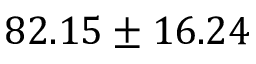Convert formula to latex. <formula><loc_0><loc_0><loc_500><loc_500>8 2 . 1 5 \pm 1 6 . 2 4</formula> 